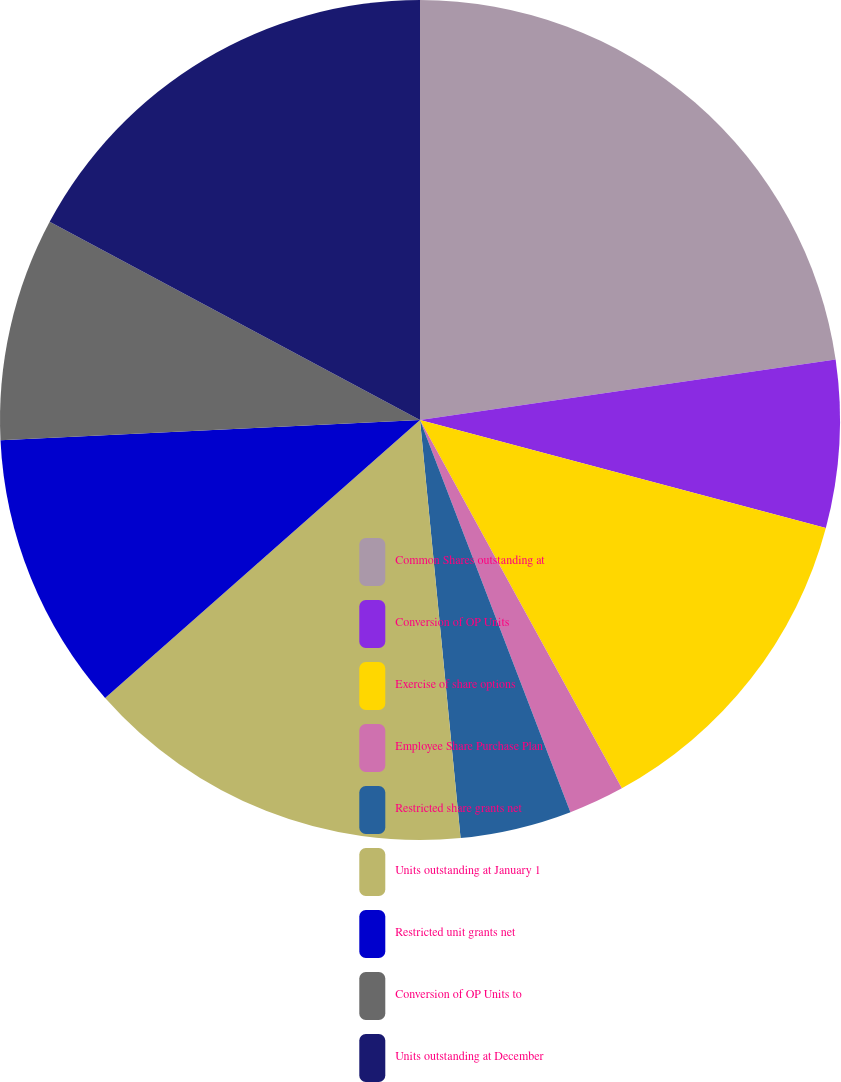Convert chart. <chart><loc_0><loc_0><loc_500><loc_500><pie_chart><fcel>Common Shares outstanding at<fcel>Conversion of OP Units<fcel>Exercise of share options<fcel>Employee Share Purchase Plan<fcel>Restricted share grants net<fcel>Units outstanding at January 1<fcel>Restricted unit grants net<fcel>Conversion of OP Units to<fcel>Units outstanding at December<nl><fcel>22.7%<fcel>6.44%<fcel>12.88%<fcel>2.15%<fcel>4.29%<fcel>15.03%<fcel>10.74%<fcel>8.59%<fcel>17.18%<nl></chart> 